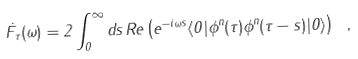Convert formula to latex. <formula><loc_0><loc_0><loc_500><loc_500>\dot { F } _ { \tau } ( \omega ) = 2 \int ^ { \infty } _ { 0 } d s \, R e \left ( e ^ { - i \omega { s } } \langle { 0 } | \phi ^ { n } ( \tau ) \phi ^ { n } ( \tau - s ) | 0 \rangle \right ) \ ,</formula> 